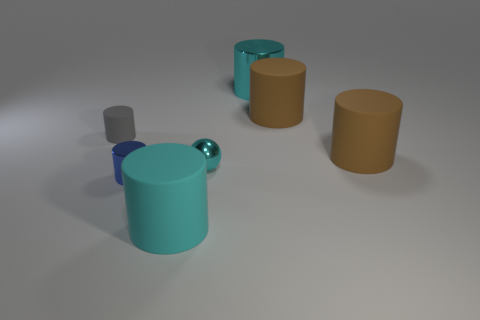Are there any tiny cyan things made of the same material as the tiny ball?
Offer a very short reply. No. There is another tiny thing that is the same shape as the gray object; what color is it?
Make the answer very short. Blue. Is the number of brown objects that are in front of the tiny blue cylinder less than the number of cyan objects left of the small gray cylinder?
Your answer should be very brief. No. What number of other things are there of the same shape as the gray rubber thing?
Provide a short and direct response. 5. Are there fewer metal cylinders right of the small blue metal cylinder than blue cylinders?
Keep it short and to the point. No. There is a tiny cylinder that is left of the tiny blue shiny cylinder; what is it made of?
Keep it short and to the point. Rubber. How many other objects are the same size as the blue metallic thing?
Make the answer very short. 2. Are there fewer large red shiny spheres than gray matte things?
Keep it short and to the point. Yes. What is the shape of the small gray object?
Give a very brief answer. Cylinder. Do the shiny cylinder that is in front of the large cyan shiny object and the tiny shiny ball have the same color?
Offer a very short reply. No. 